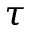Convert formula to latex. <formula><loc_0><loc_0><loc_500><loc_500>\tau</formula> 